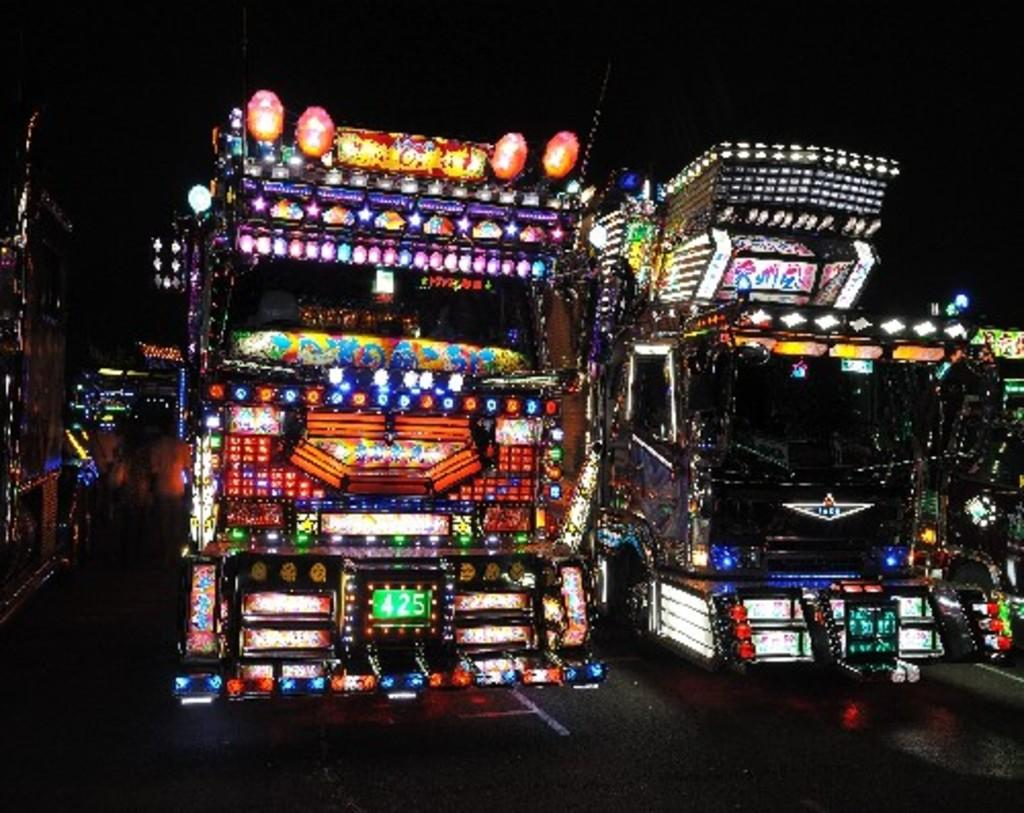What type of vehicles can be seen in the image? There are vehicles with lights in the image. Where are the vehicles located? The vehicles are on the road. What is visible at the top of the image? The sky is visible at the top of the image. What type of stocking is being used by the vehicles in the image? There is no stocking present in the image, as vehicles do not wear stockings. 